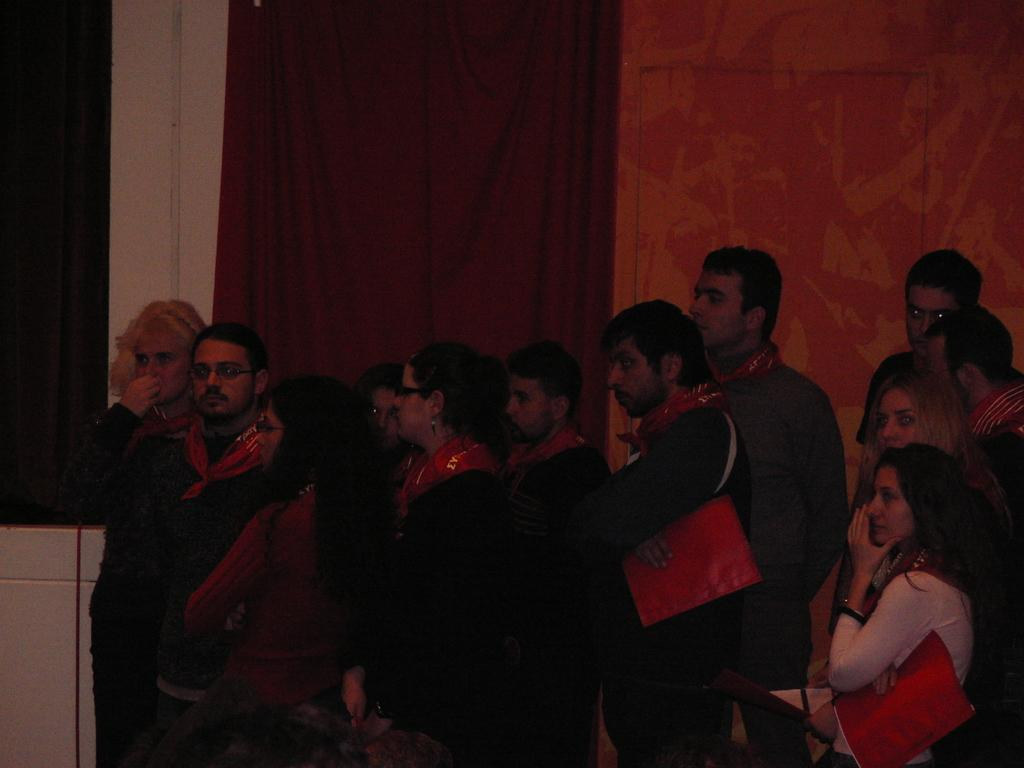What is happening in the foreground of the image? There is a group of people standing in the foreground of the image. What can be seen in the background of the image? There is a curtain and a wall in the background of the image. Can you describe the object on the left side of the image? There is a white color object on the left side of the image. What type of payment is being discussed by the group of people in the image? There is no indication in the image that the group of people is discussing payment. What idea is being shared by the group of people in the image? There is no specific idea being shared by the group of people in the image; they are simply standing together. 